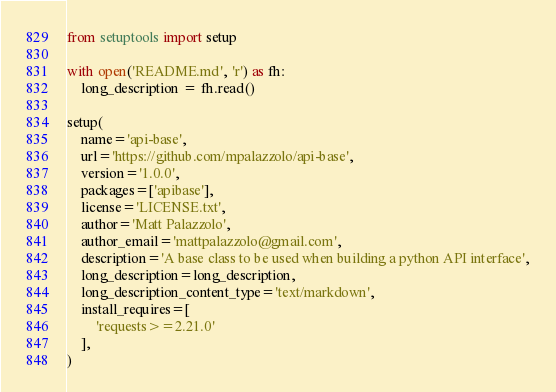Convert code to text. <code><loc_0><loc_0><loc_500><loc_500><_Python_>from setuptools import setup

with open('README.md', 'r') as fh:
    long_description = fh.read()

setup(
    name='api-base',
    url='https://github.com/mpalazzolo/api-base',
    version='1.0.0',
    packages=['apibase'],
    license='LICENSE.txt',
    author='Matt Palazzolo',
    author_email='mattpalazzolo@gmail.com',
    description='A base class to be used when building a python API interface',
    long_description=long_description,
    long_description_content_type='text/markdown',
    install_requires=[
        'requests>=2.21.0'
    ],
)
</code> 